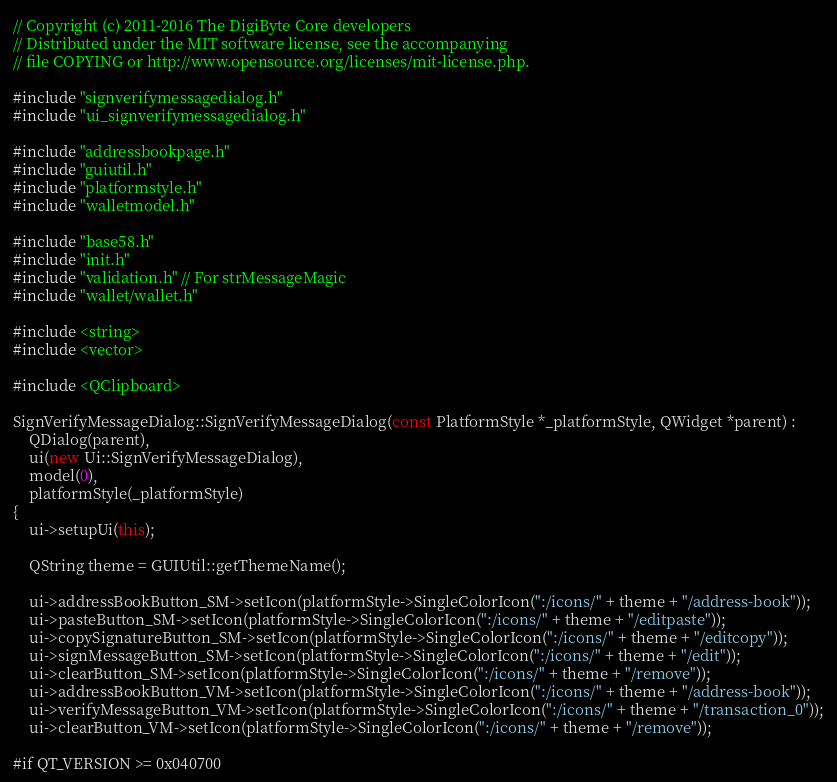Convert code to text. <code><loc_0><loc_0><loc_500><loc_500><_C++_>// Copyright (c) 2011-2016 The DigiByte Core developers
// Distributed under the MIT software license, see the accompanying
// file COPYING or http://www.opensource.org/licenses/mit-license.php.

#include "signverifymessagedialog.h"
#include "ui_signverifymessagedialog.h"

#include "addressbookpage.h"
#include "guiutil.h"
#include "platformstyle.h"
#include "walletmodel.h"

#include "base58.h"
#include "init.h"
#include "validation.h" // For strMessageMagic
#include "wallet/wallet.h"

#include <string>
#include <vector>

#include <QClipboard>

SignVerifyMessageDialog::SignVerifyMessageDialog(const PlatformStyle *_platformStyle, QWidget *parent) :
    QDialog(parent),
    ui(new Ui::SignVerifyMessageDialog),
    model(0),
    platformStyle(_platformStyle)
{
    ui->setupUi(this);

    QString theme = GUIUtil::getThemeName();

    ui->addressBookButton_SM->setIcon(platformStyle->SingleColorIcon(":/icons/" + theme + "/address-book"));
    ui->pasteButton_SM->setIcon(platformStyle->SingleColorIcon(":/icons/" + theme + "/editpaste"));
    ui->copySignatureButton_SM->setIcon(platformStyle->SingleColorIcon(":/icons/" + theme + "/editcopy"));
    ui->signMessageButton_SM->setIcon(platformStyle->SingleColorIcon(":/icons/" + theme + "/edit"));
    ui->clearButton_SM->setIcon(platformStyle->SingleColorIcon(":/icons/" + theme + "/remove"));
    ui->addressBookButton_VM->setIcon(platformStyle->SingleColorIcon(":/icons/" + theme + "/address-book"));
    ui->verifyMessageButton_VM->setIcon(platformStyle->SingleColorIcon(":/icons/" + theme + "/transaction_0"));
    ui->clearButton_VM->setIcon(platformStyle->SingleColorIcon(":/icons/" + theme + "/remove"));

#if QT_VERSION >= 0x040700</code> 